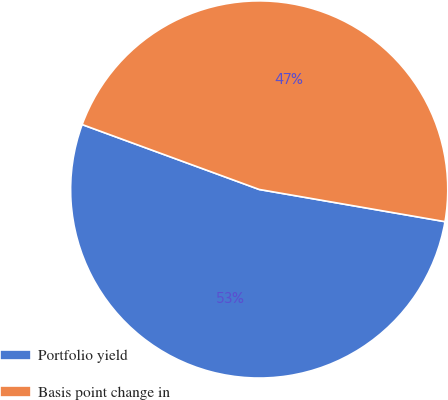<chart> <loc_0><loc_0><loc_500><loc_500><pie_chart><fcel>Portfolio yield<fcel>Basis point change in<nl><fcel>52.86%<fcel>47.14%<nl></chart> 